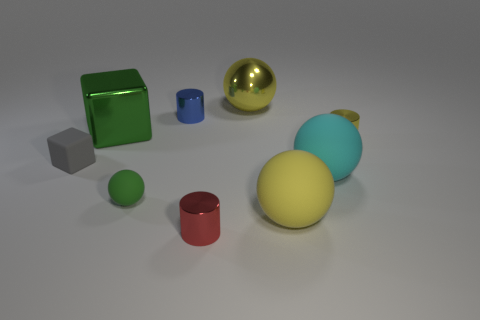Subtract all yellow spheres. How many were subtracted if there are1yellow spheres left? 1 Subtract all red shiny cylinders. How many cylinders are left? 2 Subtract all brown cylinders. How many yellow spheres are left? 2 Add 1 big blocks. How many objects exist? 10 Subtract all cyan spheres. How many spheres are left? 3 Add 9 gray cubes. How many gray cubes are left? 10 Add 5 small rubber cylinders. How many small rubber cylinders exist? 5 Subtract 0 red cubes. How many objects are left? 9 Subtract all cylinders. How many objects are left? 6 Subtract all purple spheres. Subtract all red blocks. How many spheres are left? 4 